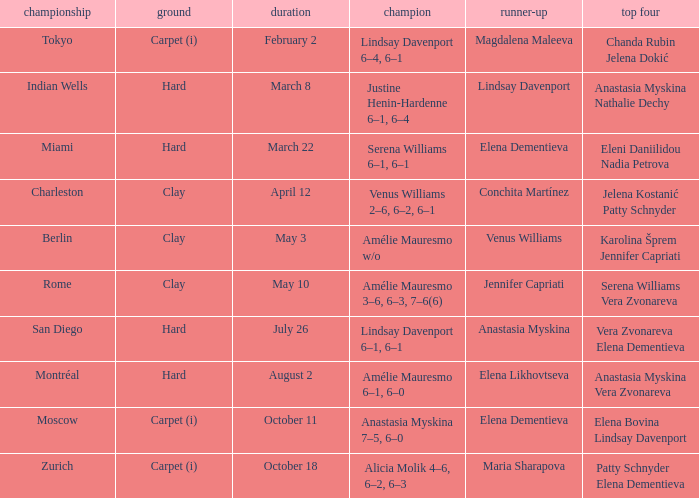Who was the finalist of the hard surface tournament in Miami? Elena Dementieva. 